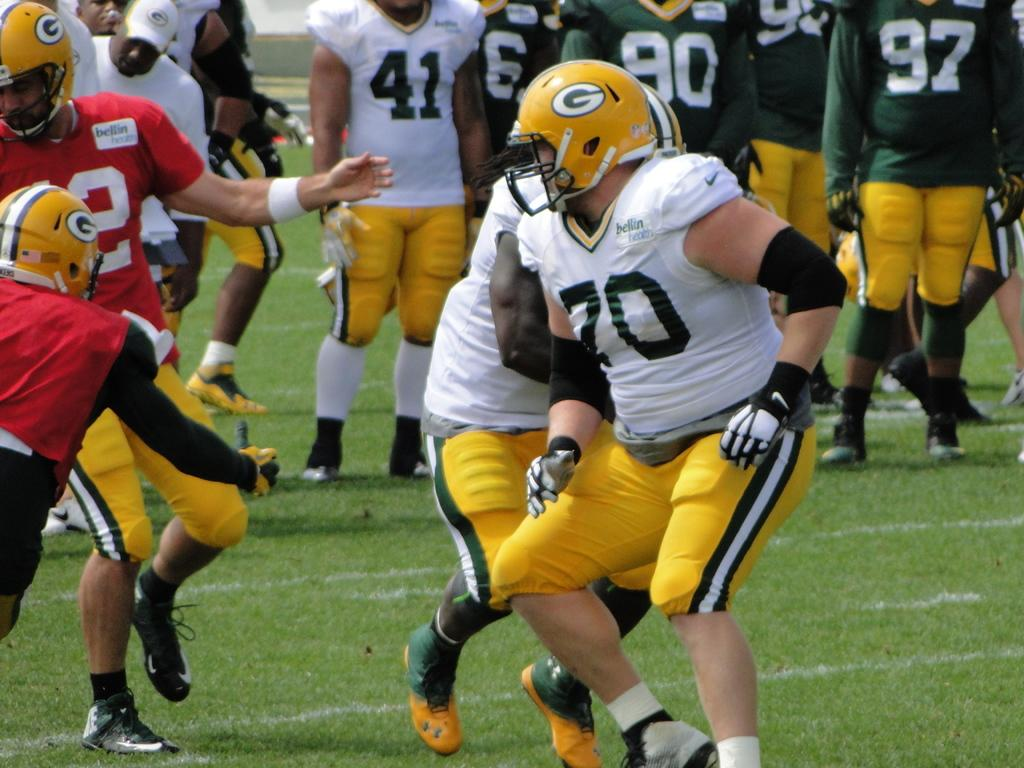What is the main subject of the image? The main subject of the image is a group of people. What are the people wearing in the image? The people are wearing dresses and helmets in the image. What is the surface on which the people are standing? The people are standing on the ground in the image. What flavor of ice cream can be seen in the moon in the image? There is no ice cream or moon present in the image; it features a group of people wearing dresses and helmets while standing on the ground. 